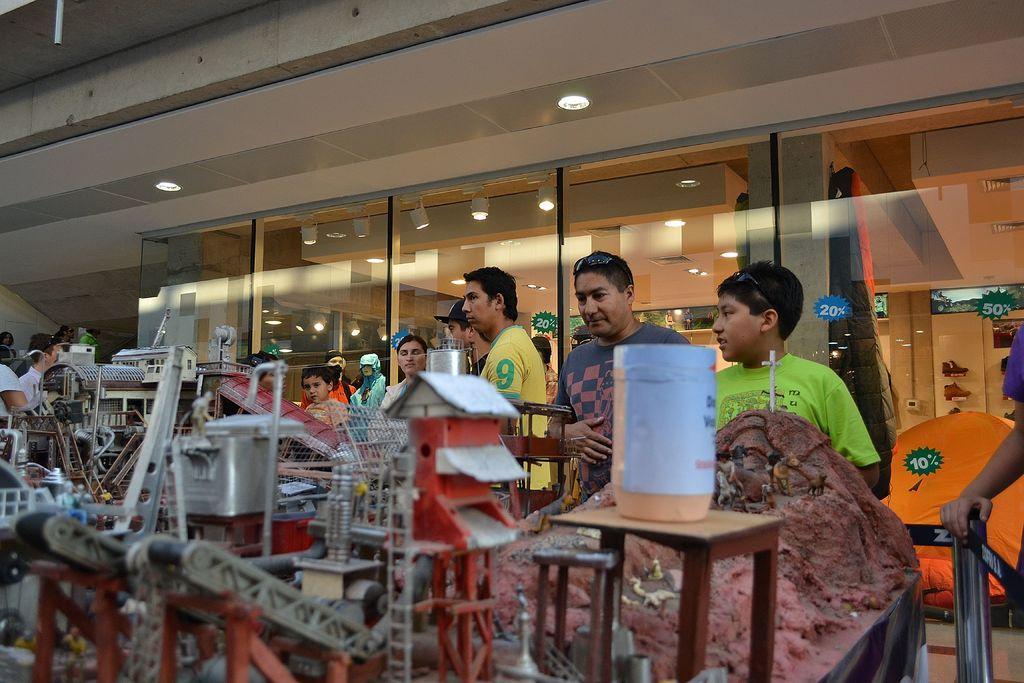Please provide a concise description of this image. In this image we can see a few objects, people standing here, glass doors and the ceiling lights. 